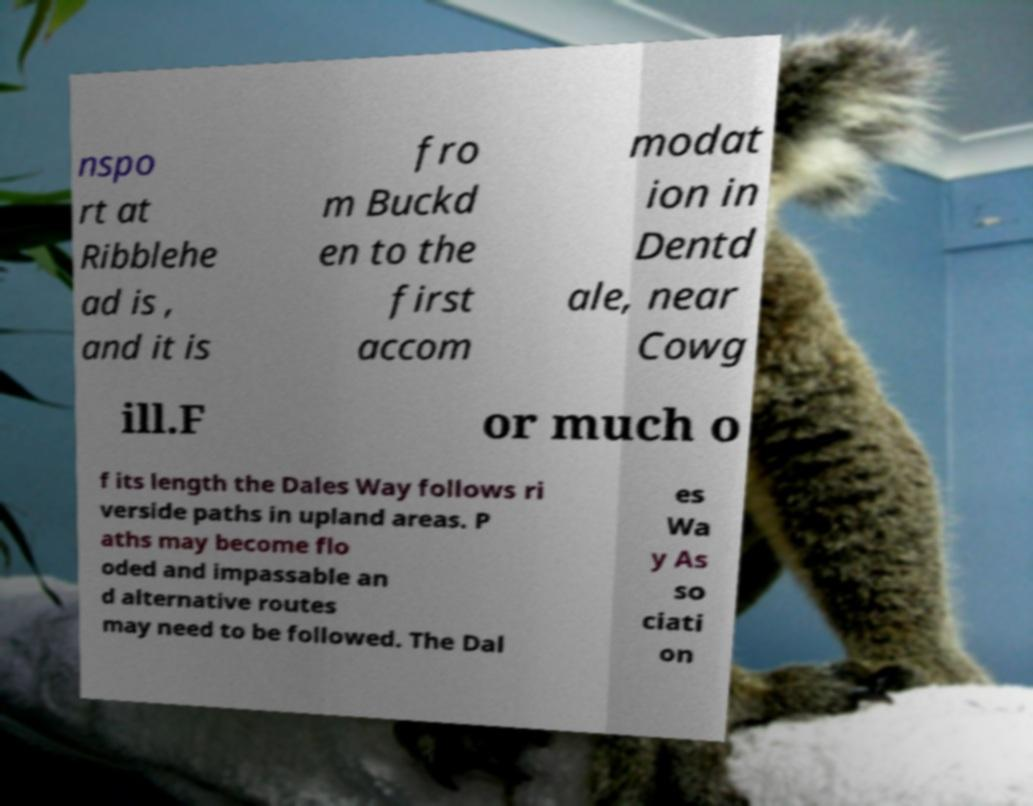There's text embedded in this image that I need extracted. Can you transcribe it verbatim? nspo rt at Ribblehe ad is , and it is fro m Buckd en to the first accom modat ion in Dentd ale, near Cowg ill.F or much o f its length the Dales Way follows ri verside paths in upland areas. P aths may become flo oded and impassable an d alternative routes may need to be followed. The Dal es Wa y As so ciati on 